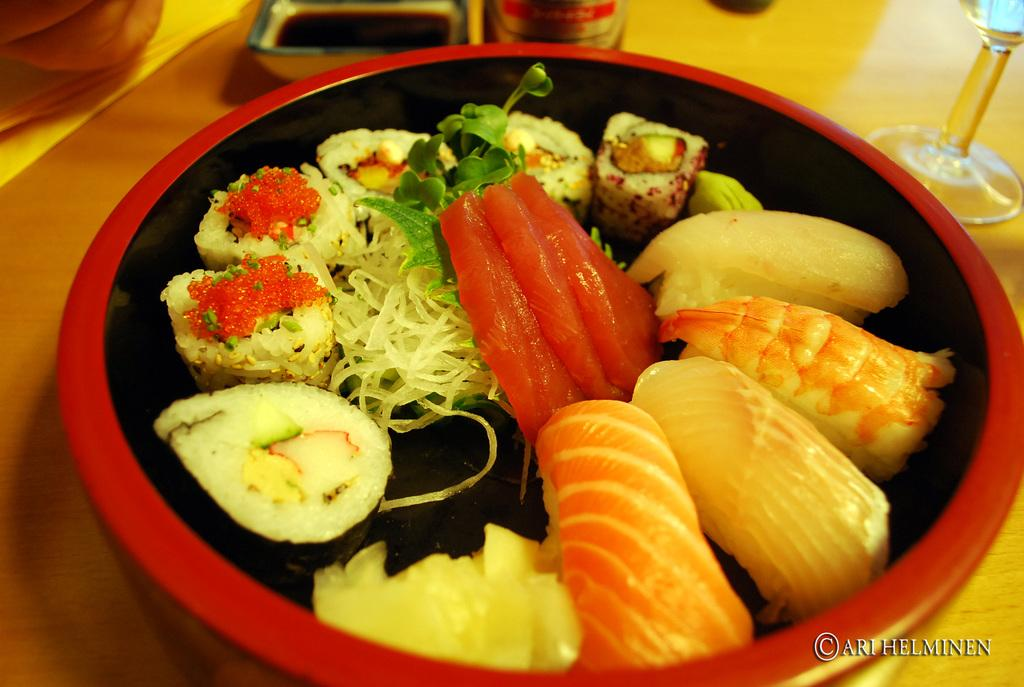What is in the bowl that is visible in the image? There is a bowl containing food in the image. Where is the bowl located in the image? The bowl is placed on a surface. What can be seen in the background of the image? There is a bowl with liquid and a glass in the background of the image, as well as other objects on the table. What type of scarf is being used as a finger puppet in the image? There is no scarf or finger puppet present in the image. 